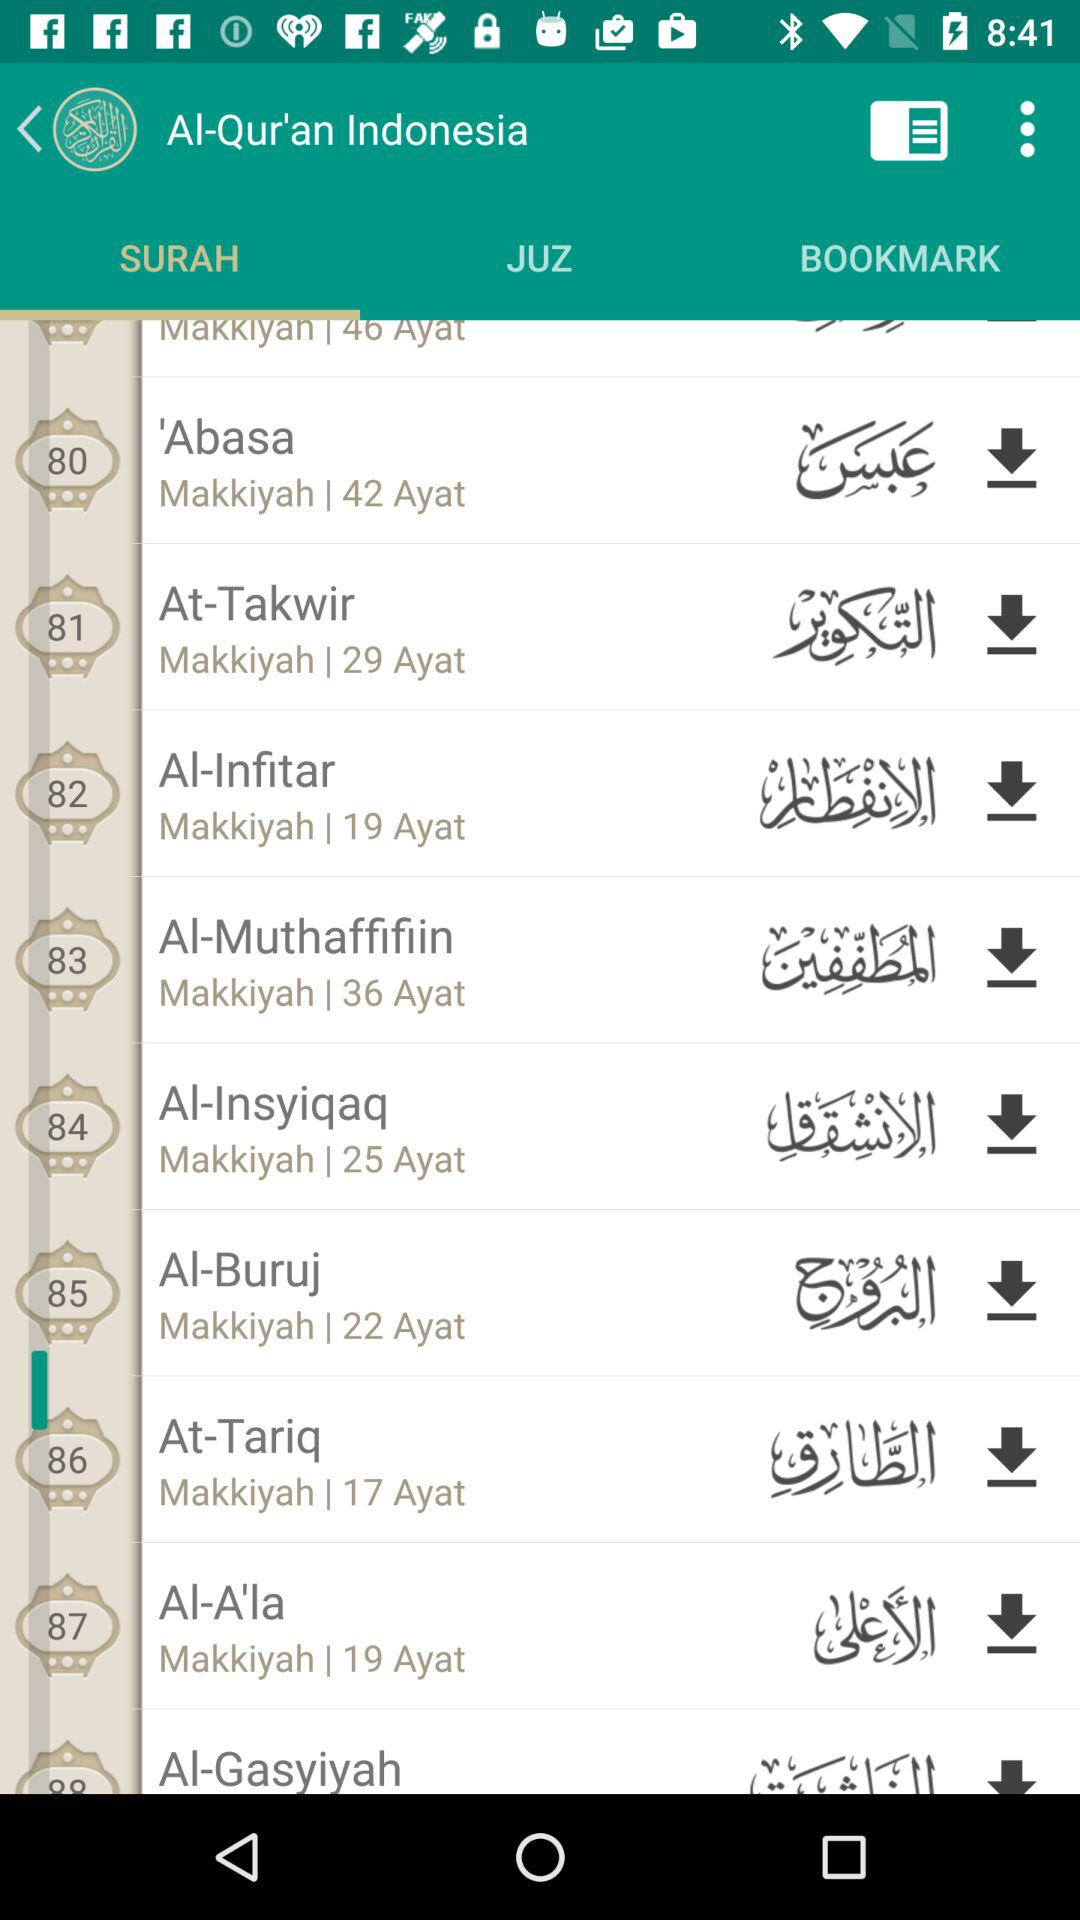How many verses are in the surah 'Abasa?
Answer the question using a single word or phrase. 42 